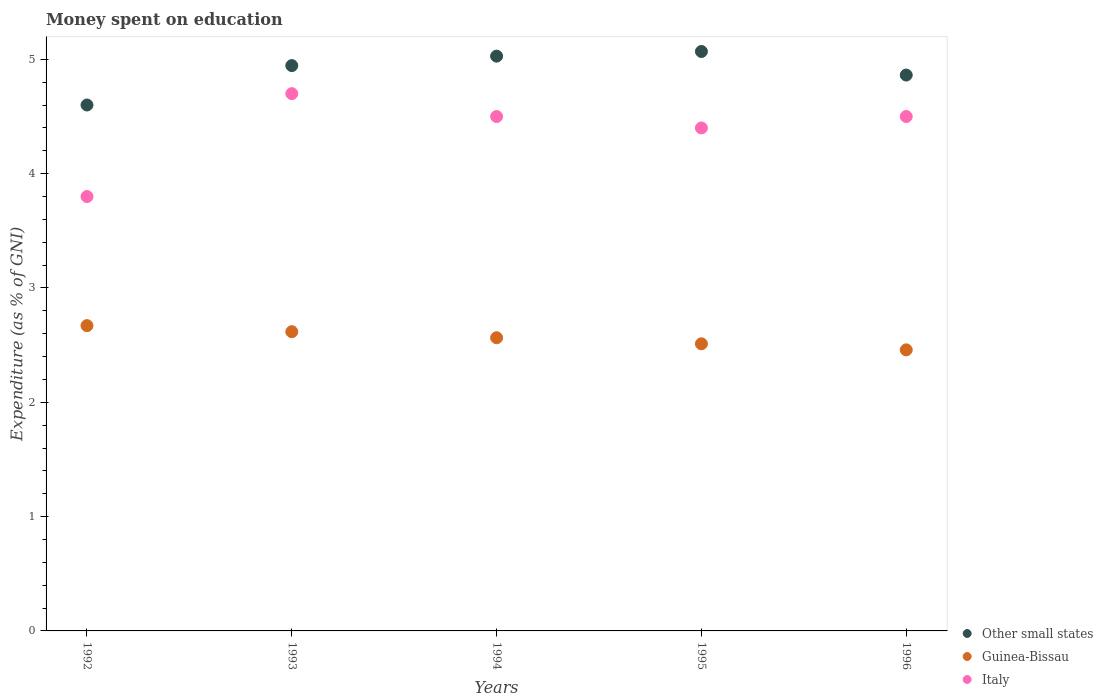What is the amount of money spent on education in Italy in 1995?
Give a very brief answer. 4.4. Across all years, what is the maximum amount of money spent on education in Guinea-Bissau?
Keep it short and to the point. 2.67. Across all years, what is the minimum amount of money spent on education in Other small states?
Give a very brief answer. 4.6. In which year was the amount of money spent on education in Guinea-Bissau minimum?
Provide a succinct answer. 1996. What is the total amount of money spent on education in Other small states in the graph?
Your response must be concise. 24.51. What is the difference between the amount of money spent on education in Guinea-Bissau in 1994 and that in 1996?
Your response must be concise. 0.11. What is the difference between the amount of money spent on education in Italy in 1993 and the amount of money spent on education in Other small states in 1994?
Your answer should be compact. -0.33. What is the average amount of money spent on education in Guinea-Bissau per year?
Your answer should be very brief. 2.56. In the year 1992, what is the difference between the amount of money spent on education in Guinea-Bissau and amount of money spent on education in Italy?
Your response must be concise. -1.13. What is the ratio of the amount of money spent on education in Italy in 1992 to that in 1995?
Provide a succinct answer. 0.86. Is the amount of money spent on education in Italy in 1994 less than that in 1996?
Provide a succinct answer. No. Is the difference between the amount of money spent on education in Guinea-Bissau in 1993 and 1996 greater than the difference between the amount of money spent on education in Italy in 1993 and 1996?
Give a very brief answer. No. What is the difference between the highest and the second highest amount of money spent on education in Guinea-Bissau?
Your answer should be very brief. 0.05. What is the difference between the highest and the lowest amount of money spent on education in Italy?
Offer a very short reply. 0.9. Is it the case that in every year, the sum of the amount of money spent on education in Other small states and amount of money spent on education in Italy  is greater than the amount of money spent on education in Guinea-Bissau?
Provide a succinct answer. Yes. Does the amount of money spent on education in Italy monotonically increase over the years?
Your answer should be compact. No. Is the amount of money spent on education in Italy strictly greater than the amount of money spent on education in Other small states over the years?
Your response must be concise. No. Is the amount of money spent on education in Guinea-Bissau strictly less than the amount of money spent on education in Other small states over the years?
Provide a succinct answer. Yes. How many dotlines are there?
Your answer should be very brief. 3. What is the difference between two consecutive major ticks on the Y-axis?
Ensure brevity in your answer.  1. Are the values on the major ticks of Y-axis written in scientific E-notation?
Your answer should be very brief. No. Does the graph contain any zero values?
Provide a succinct answer. No. Where does the legend appear in the graph?
Make the answer very short. Bottom right. How many legend labels are there?
Your answer should be very brief. 3. What is the title of the graph?
Your answer should be very brief. Money spent on education. What is the label or title of the X-axis?
Offer a very short reply. Years. What is the label or title of the Y-axis?
Your answer should be compact. Expenditure (as % of GNI). What is the Expenditure (as % of GNI) of Other small states in 1992?
Provide a succinct answer. 4.6. What is the Expenditure (as % of GNI) of Guinea-Bissau in 1992?
Offer a very short reply. 2.67. What is the Expenditure (as % of GNI) in Italy in 1992?
Make the answer very short. 3.8. What is the Expenditure (as % of GNI) of Other small states in 1993?
Give a very brief answer. 4.95. What is the Expenditure (as % of GNI) of Guinea-Bissau in 1993?
Provide a short and direct response. 2.62. What is the Expenditure (as % of GNI) in Italy in 1993?
Ensure brevity in your answer.  4.7. What is the Expenditure (as % of GNI) in Other small states in 1994?
Offer a very short reply. 5.03. What is the Expenditure (as % of GNI) of Guinea-Bissau in 1994?
Your answer should be very brief. 2.56. What is the Expenditure (as % of GNI) of Other small states in 1995?
Make the answer very short. 5.07. What is the Expenditure (as % of GNI) of Guinea-Bissau in 1995?
Your response must be concise. 2.51. What is the Expenditure (as % of GNI) in Italy in 1995?
Your response must be concise. 4.4. What is the Expenditure (as % of GNI) of Other small states in 1996?
Keep it short and to the point. 4.86. What is the Expenditure (as % of GNI) of Guinea-Bissau in 1996?
Your answer should be compact. 2.46. What is the Expenditure (as % of GNI) in Italy in 1996?
Give a very brief answer. 4.5. Across all years, what is the maximum Expenditure (as % of GNI) in Other small states?
Make the answer very short. 5.07. Across all years, what is the maximum Expenditure (as % of GNI) of Guinea-Bissau?
Provide a short and direct response. 2.67. Across all years, what is the minimum Expenditure (as % of GNI) of Other small states?
Make the answer very short. 4.6. Across all years, what is the minimum Expenditure (as % of GNI) in Guinea-Bissau?
Offer a terse response. 2.46. Across all years, what is the minimum Expenditure (as % of GNI) of Italy?
Offer a terse response. 3.8. What is the total Expenditure (as % of GNI) of Other small states in the graph?
Your answer should be compact. 24.51. What is the total Expenditure (as % of GNI) of Guinea-Bissau in the graph?
Ensure brevity in your answer.  12.82. What is the total Expenditure (as % of GNI) in Italy in the graph?
Your answer should be very brief. 21.9. What is the difference between the Expenditure (as % of GNI) of Other small states in 1992 and that in 1993?
Offer a terse response. -0.34. What is the difference between the Expenditure (as % of GNI) of Guinea-Bissau in 1992 and that in 1993?
Provide a short and direct response. 0.05. What is the difference between the Expenditure (as % of GNI) of Italy in 1992 and that in 1993?
Ensure brevity in your answer.  -0.9. What is the difference between the Expenditure (as % of GNI) of Other small states in 1992 and that in 1994?
Ensure brevity in your answer.  -0.43. What is the difference between the Expenditure (as % of GNI) in Guinea-Bissau in 1992 and that in 1994?
Make the answer very short. 0.11. What is the difference between the Expenditure (as % of GNI) of Italy in 1992 and that in 1994?
Offer a very short reply. -0.7. What is the difference between the Expenditure (as % of GNI) in Other small states in 1992 and that in 1995?
Keep it short and to the point. -0.47. What is the difference between the Expenditure (as % of GNI) in Guinea-Bissau in 1992 and that in 1995?
Keep it short and to the point. 0.16. What is the difference between the Expenditure (as % of GNI) in Italy in 1992 and that in 1995?
Give a very brief answer. -0.6. What is the difference between the Expenditure (as % of GNI) of Other small states in 1992 and that in 1996?
Give a very brief answer. -0.26. What is the difference between the Expenditure (as % of GNI) in Guinea-Bissau in 1992 and that in 1996?
Make the answer very short. 0.21. What is the difference between the Expenditure (as % of GNI) in Other small states in 1993 and that in 1994?
Your answer should be very brief. -0.08. What is the difference between the Expenditure (as % of GNI) of Guinea-Bissau in 1993 and that in 1994?
Make the answer very short. 0.05. What is the difference between the Expenditure (as % of GNI) of Italy in 1993 and that in 1994?
Make the answer very short. 0.2. What is the difference between the Expenditure (as % of GNI) of Other small states in 1993 and that in 1995?
Offer a very short reply. -0.12. What is the difference between the Expenditure (as % of GNI) in Guinea-Bissau in 1993 and that in 1995?
Give a very brief answer. 0.11. What is the difference between the Expenditure (as % of GNI) of Other small states in 1993 and that in 1996?
Your answer should be very brief. 0.08. What is the difference between the Expenditure (as % of GNI) of Guinea-Bissau in 1993 and that in 1996?
Make the answer very short. 0.16. What is the difference between the Expenditure (as % of GNI) in Italy in 1993 and that in 1996?
Offer a very short reply. 0.2. What is the difference between the Expenditure (as % of GNI) in Other small states in 1994 and that in 1995?
Provide a short and direct response. -0.04. What is the difference between the Expenditure (as % of GNI) of Guinea-Bissau in 1994 and that in 1995?
Ensure brevity in your answer.  0.05. What is the difference between the Expenditure (as % of GNI) in Italy in 1994 and that in 1995?
Make the answer very short. 0.1. What is the difference between the Expenditure (as % of GNI) of Other small states in 1994 and that in 1996?
Keep it short and to the point. 0.17. What is the difference between the Expenditure (as % of GNI) of Guinea-Bissau in 1994 and that in 1996?
Your answer should be very brief. 0.11. What is the difference between the Expenditure (as % of GNI) of Italy in 1994 and that in 1996?
Provide a short and direct response. 0. What is the difference between the Expenditure (as % of GNI) of Other small states in 1995 and that in 1996?
Make the answer very short. 0.21. What is the difference between the Expenditure (as % of GNI) of Guinea-Bissau in 1995 and that in 1996?
Your answer should be compact. 0.05. What is the difference between the Expenditure (as % of GNI) in Italy in 1995 and that in 1996?
Offer a very short reply. -0.1. What is the difference between the Expenditure (as % of GNI) of Other small states in 1992 and the Expenditure (as % of GNI) of Guinea-Bissau in 1993?
Ensure brevity in your answer.  1.98. What is the difference between the Expenditure (as % of GNI) in Other small states in 1992 and the Expenditure (as % of GNI) in Italy in 1993?
Provide a short and direct response. -0.1. What is the difference between the Expenditure (as % of GNI) of Guinea-Bissau in 1992 and the Expenditure (as % of GNI) of Italy in 1993?
Ensure brevity in your answer.  -2.03. What is the difference between the Expenditure (as % of GNI) of Other small states in 1992 and the Expenditure (as % of GNI) of Guinea-Bissau in 1994?
Your answer should be very brief. 2.04. What is the difference between the Expenditure (as % of GNI) in Other small states in 1992 and the Expenditure (as % of GNI) in Italy in 1994?
Offer a very short reply. 0.1. What is the difference between the Expenditure (as % of GNI) of Guinea-Bissau in 1992 and the Expenditure (as % of GNI) of Italy in 1994?
Your response must be concise. -1.83. What is the difference between the Expenditure (as % of GNI) of Other small states in 1992 and the Expenditure (as % of GNI) of Guinea-Bissau in 1995?
Provide a succinct answer. 2.09. What is the difference between the Expenditure (as % of GNI) in Other small states in 1992 and the Expenditure (as % of GNI) in Italy in 1995?
Ensure brevity in your answer.  0.2. What is the difference between the Expenditure (as % of GNI) of Guinea-Bissau in 1992 and the Expenditure (as % of GNI) of Italy in 1995?
Give a very brief answer. -1.73. What is the difference between the Expenditure (as % of GNI) in Other small states in 1992 and the Expenditure (as % of GNI) in Guinea-Bissau in 1996?
Give a very brief answer. 2.14. What is the difference between the Expenditure (as % of GNI) in Other small states in 1992 and the Expenditure (as % of GNI) in Italy in 1996?
Your response must be concise. 0.1. What is the difference between the Expenditure (as % of GNI) of Guinea-Bissau in 1992 and the Expenditure (as % of GNI) of Italy in 1996?
Provide a succinct answer. -1.83. What is the difference between the Expenditure (as % of GNI) in Other small states in 1993 and the Expenditure (as % of GNI) in Guinea-Bissau in 1994?
Provide a short and direct response. 2.38. What is the difference between the Expenditure (as % of GNI) of Other small states in 1993 and the Expenditure (as % of GNI) of Italy in 1994?
Your response must be concise. 0.45. What is the difference between the Expenditure (as % of GNI) of Guinea-Bissau in 1993 and the Expenditure (as % of GNI) of Italy in 1994?
Make the answer very short. -1.88. What is the difference between the Expenditure (as % of GNI) in Other small states in 1993 and the Expenditure (as % of GNI) in Guinea-Bissau in 1995?
Ensure brevity in your answer.  2.43. What is the difference between the Expenditure (as % of GNI) of Other small states in 1993 and the Expenditure (as % of GNI) of Italy in 1995?
Ensure brevity in your answer.  0.55. What is the difference between the Expenditure (as % of GNI) in Guinea-Bissau in 1993 and the Expenditure (as % of GNI) in Italy in 1995?
Your answer should be very brief. -1.78. What is the difference between the Expenditure (as % of GNI) of Other small states in 1993 and the Expenditure (as % of GNI) of Guinea-Bissau in 1996?
Provide a succinct answer. 2.49. What is the difference between the Expenditure (as % of GNI) in Other small states in 1993 and the Expenditure (as % of GNI) in Italy in 1996?
Provide a short and direct response. 0.45. What is the difference between the Expenditure (as % of GNI) of Guinea-Bissau in 1993 and the Expenditure (as % of GNI) of Italy in 1996?
Provide a short and direct response. -1.88. What is the difference between the Expenditure (as % of GNI) of Other small states in 1994 and the Expenditure (as % of GNI) of Guinea-Bissau in 1995?
Your answer should be compact. 2.52. What is the difference between the Expenditure (as % of GNI) of Other small states in 1994 and the Expenditure (as % of GNI) of Italy in 1995?
Offer a very short reply. 0.63. What is the difference between the Expenditure (as % of GNI) in Guinea-Bissau in 1994 and the Expenditure (as % of GNI) in Italy in 1995?
Provide a succinct answer. -1.84. What is the difference between the Expenditure (as % of GNI) of Other small states in 1994 and the Expenditure (as % of GNI) of Guinea-Bissau in 1996?
Ensure brevity in your answer.  2.57. What is the difference between the Expenditure (as % of GNI) of Other small states in 1994 and the Expenditure (as % of GNI) of Italy in 1996?
Ensure brevity in your answer.  0.53. What is the difference between the Expenditure (as % of GNI) in Guinea-Bissau in 1994 and the Expenditure (as % of GNI) in Italy in 1996?
Offer a very short reply. -1.94. What is the difference between the Expenditure (as % of GNI) of Other small states in 1995 and the Expenditure (as % of GNI) of Guinea-Bissau in 1996?
Keep it short and to the point. 2.61. What is the difference between the Expenditure (as % of GNI) of Other small states in 1995 and the Expenditure (as % of GNI) of Italy in 1996?
Provide a succinct answer. 0.57. What is the difference between the Expenditure (as % of GNI) of Guinea-Bissau in 1995 and the Expenditure (as % of GNI) of Italy in 1996?
Provide a short and direct response. -1.99. What is the average Expenditure (as % of GNI) in Other small states per year?
Provide a short and direct response. 4.9. What is the average Expenditure (as % of GNI) of Guinea-Bissau per year?
Provide a short and direct response. 2.56. What is the average Expenditure (as % of GNI) of Italy per year?
Provide a succinct answer. 4.38. In the year 1992, what is the difference between the Expenditure (as % of GNI) in Other small states and Expenditure (as % of GNI) in Guinea-Bissau?
Provide a succinct answer. 1.93. In the year 1992, what is the difference between the Expenditure (as % of GNI) of Other small states and Expenditure (as % of GNI) of Italy?
Make the answer very short. 0.8. In the year 1992, what is the difference between the Expenditure (as % of GNI) in Guinea-Bissau and Expenditure (as % of GNI) in Italy?
Your answer should be very brief. -1.13. In the year 1993, what is the difference between the Expenditure (as % of GNI) in Other small states and Expenditure (as % of GNI) in Guinea-Bissau?
Offer a terse response. 2.33. In the year 1993, what is the difference between the Expenditure (as % of GNI) in Other small states and Expenditure (as % of GNI) in Italy?
Offer a very short reply. 0.25. In the year 1993, what is the difference between the Expenditure (as % of GNI) of Guinea-Bissau and Expenditure (as % of GNI) of Italy?
Your answer should be compact. -2.08. In the year 1994, what is the difference between the Expenditure (as % of GNI) in Other small states and Expenditure (as % of GNI) in Guinea-Bissau?
Offer a terse response. 2.46. In the year 1994, what is the difference between the Expenditure (as % of GNI) in Other small states and Expenditure (as % of GNI) in Italy?
Provide a succinct answer. 0.53. In the year 1994, what is the difference between the Expenditure (as % of GNI) of Guinea-Bissau and Expenditure (as % of GNI) of Italy?
Provide a short and direct response. -1.94. In the year 1995, what is the difference between the Expenditure (as % of GNI) in Other small states and Expenditure (as % of GNI) in Guinea-Bissau?
Provide a short and direct response. 2.56. In the year 1995, what is the difference between the Expenditure (as % of GNI) of Other small states and Expenditure (as % of GNI) of Italy?
Provide a succinct answer. 0.67. In the year 1995, what is the difference between the Expenditure (as % of GNI) in Guinea-Bissau and Expenditure (as % of GNI) in Italy?
Your response must be concise. -1.89. In the year 1996, what is the difference between the Expenditure (as % of GNI) of Other small states and Expenditure (as % of GNI) of Guinea-Bissau?
Your answer should be very brief. 2.4. In the year 1996, what is the difference between the Expenditure (as % of GNI) in Other small states and Expenditure (as % of GNI) in Italy?
Your response must be concise. 0.36. In the year 1996, what is the difference between the Expenditure (as % of GNI) of Guinea-Bissau and Expenditure (as % of GNI) of Italy?
Give a very brief answer. -2.04. What is the ratio of the Expenditure (as % of GNI) in Other small states in 1992 to that in 1993?
Give a very brief answer. 0.93. What is the ratio of the Expenditure (as % of GNI) in Guinea-Bissau in 1992 to that in 1993?
Provide a short and direct response. 1.02. What is the ratio of the Expenditure (as % of GNI) in Italy in 1992 to that in 1993?
Give a very brief answer. 0.81. What is the ratio of the Expenditure (as % of GNI) in Other small states in 1992 to that in 1994?
Your response must be concise. 0.92. What is the ratio of the Expenditure (as % of GNI) in Guinea-Bissau in 1992 to that in 1994?
Keep it short and to the point. 1.04. What is the ratio of the Expenditure (as % of GNI) of Italy in 1992 to that in 1994?
Give a very brief answer. 0.84. What is the ratio of the Expenditure (as % of GNI) of Other small states in 1992 to that in 1995?
Your answer should be very brief. 0.91. What is the ratio of the Expenditure (as % of GNI) in Guinea-Bissau in 1992 to that in 1995?
Provide a short and direct response. 1.06. What is the ratio of the Expenditure (as % of GNI) in Italy in 1992 to that in 1995?
Your answer should be very brief. 0.86. What is the ratio of the Expenditure (as % of GNI) in Other small states in 1992 to that in 1996?
Your answer should be very brief. 0.95. What is the ratio of the Expenditure (as % of GNI) of Guinea-Bissau in 1992 to that in 1996?
Provide a short and direct response. 1.09. What is the ratio of the Expenditure (as % of GNI) in Italy in 1992 to that in 1996?
Provide a short and direct response. 0.84. What is the ratio of the Expenditure (as % of GNI) in Other small states in 1993 to that in 1994?
Offer a terse response. 0.98. What is the ratio of the Expenditure (as % of GNI) of Guinea-Bissau in 1993 to that in 1994?
Your answer should be compact. 1.02. What is the ratio of the Expenditure (as % of GNI) of Italy in 1993 to that in 1994?
Make the answer very short. 1.04. What is the ratio of the Expenditure (as % of GNI) in Other small states in 1993 to that in 1995?
Your answer should be very brief. 0.98. What is the ratio of the Expenditure (as % of GNI) in Guinea-Bissau in 1993 to that in 1995?
Make the answer very short. 1.04. What is the ratio of the Expenditure (as % of GNI) of Italy in 1993 to that in 1995?
Ensure brevity in your answer.  1.07. What is the ratio of the Expenditure (as % of GNI) in Other small states in 1993 to that in 1996?
Provide a succinct answer. 1.02. What is the ratio of the Expenditure (as % of GNI) of Guinea-Bissau in 1993 to that in 1996?
Provide a short and direct response. 1.06. What is the ratio of the Expenditure (as % of GNI) of Italy in 1993 to that in 1996?
Your answer should be very brief. 1.04. What is the ratio of the Expenditure (as % of GNI) of Guinea-Bissau in 1994 to that in 1995?
Ensure brevity in your answer.  1.02. What is the ratio of the Expenditure (as % of GNI) of Italy in 1994 to that in 1995?
Provide a short and direct response. 1.02. What is the ratio of the Expenditure (as % of GNI) of Other small states in 1994 to that in 1996?
Make the answer very short. 1.03. What is the ratio of the Expenditure (as % of GNI) of Guinea-Bissau in 1994 to that in 1996?
Keep it short and to the point. 1.04. What is the ratio of the Expenditure (as % of GNI) of Italy in 1994 to that in 1996?
Your answer should be very brief. 1. What is the ratio of the Expenditure (as % of GNI) of Other small states in 1995 to that in 1996?
Your answer should be compact. 1.04. What is the ratio of the Expenditure (as % of GNI) of Guinea-Bissau in 1995 to that in 1996?
Your answer should be very brief. 1.02. What is the ratio of the Expenditure (as % of GNI) in Italy in 1995 to that in 1996?
Ensure brevity in your answer.  0.98. What is the difference between the highest and the second highest Expenditure (as % of GNI) of Other small states?
Keep it short and to the point. 0.04. What is the difference between the highest and the second highest Expenditure (as % of GNI) of Guinea-Bissau?
Make the answer very short. 0.05. What is the difference between the highest and the lowest Expenditure (as % of GNI) of Other small states?
Make the answer very short. 0.47. What is the difference between the highest and the lowest Expenditure (as % of GNI) of Guinea-Bissau?
Provide a succinct answer. 0.21. What is the difference between the highest and the lowest Expenditure (as % of GNI) in Italy?
Give a very brief answer. 0.9. 